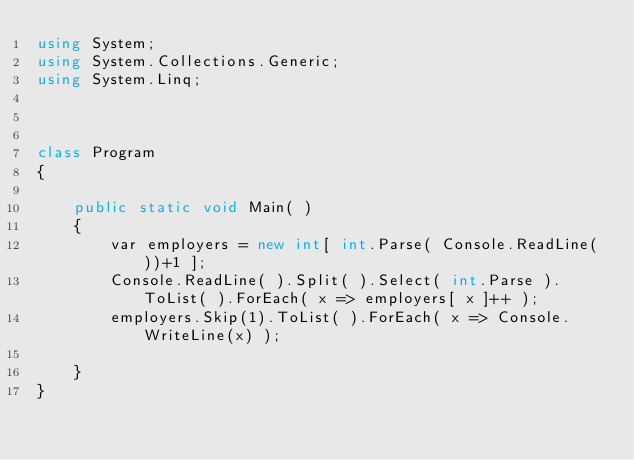<code> <loc_0><loc_0><loc_500><loc_500><_C#_>using System;
using System.Collections.Generic;
using System.Linq;



class Program
{
 
    public static void Main( )
    {
        var employers = new int[ int.Parse( Console.ReadLine( ))+1 ];
        Console.ReadLine( ).Split( ).Select( int.Parse ).ToList( ).ForEach( x => employers[ x ]++ );
        employers.Skip(1).ToList( ).ForEach( x => Console.WriteLine(x) );

    }
}


</code> 